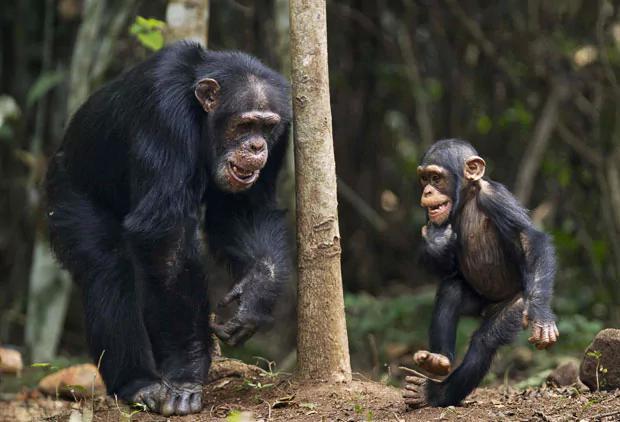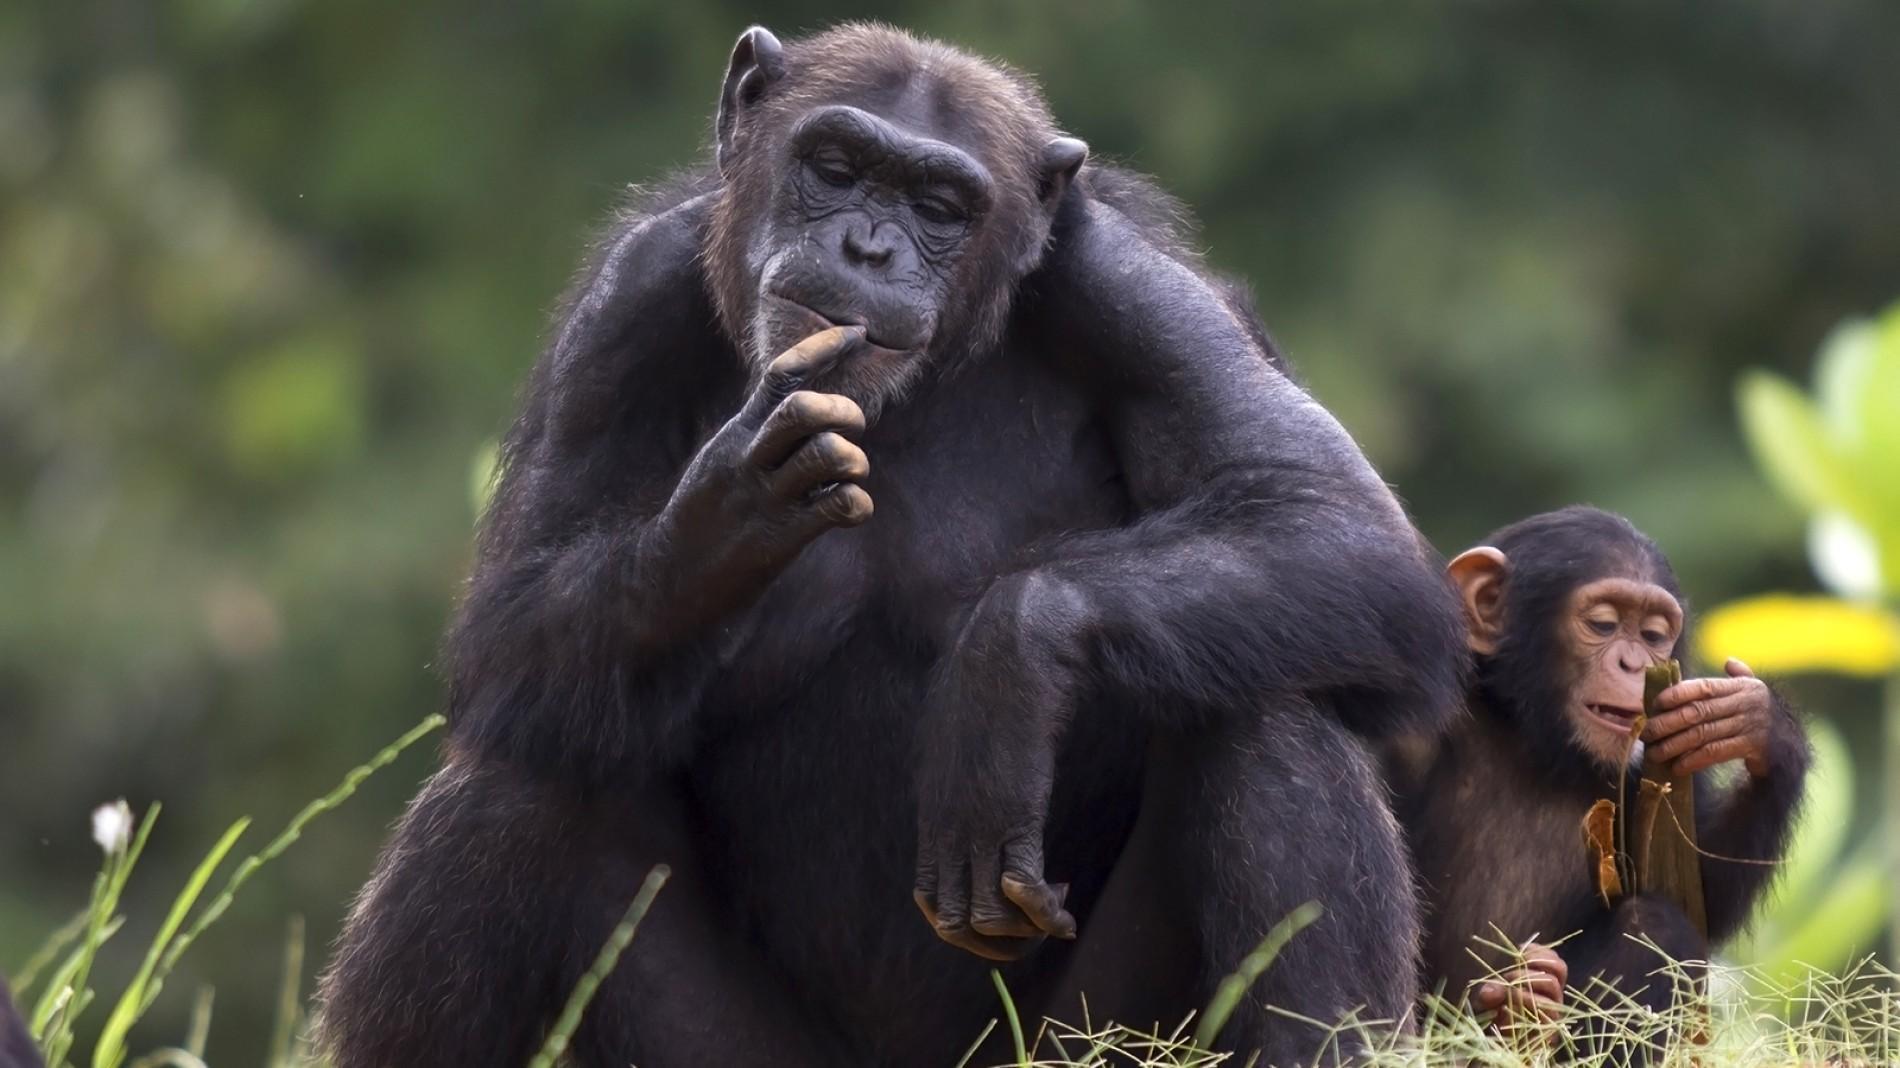The first image is the image on the left, the second image is the image on the right. Examine the images to the left and right. Is the description "Just one adult and one young chimp are interacting side-by-side in the left image." accurate? Answer yes or no. Yes. The first image is the image on the left, the second image is the image on the right. Examine the images to the left and right. Is the description "There is exactly one baby monkey in the image on the right." accurate? Answer yes or no. Yes. 